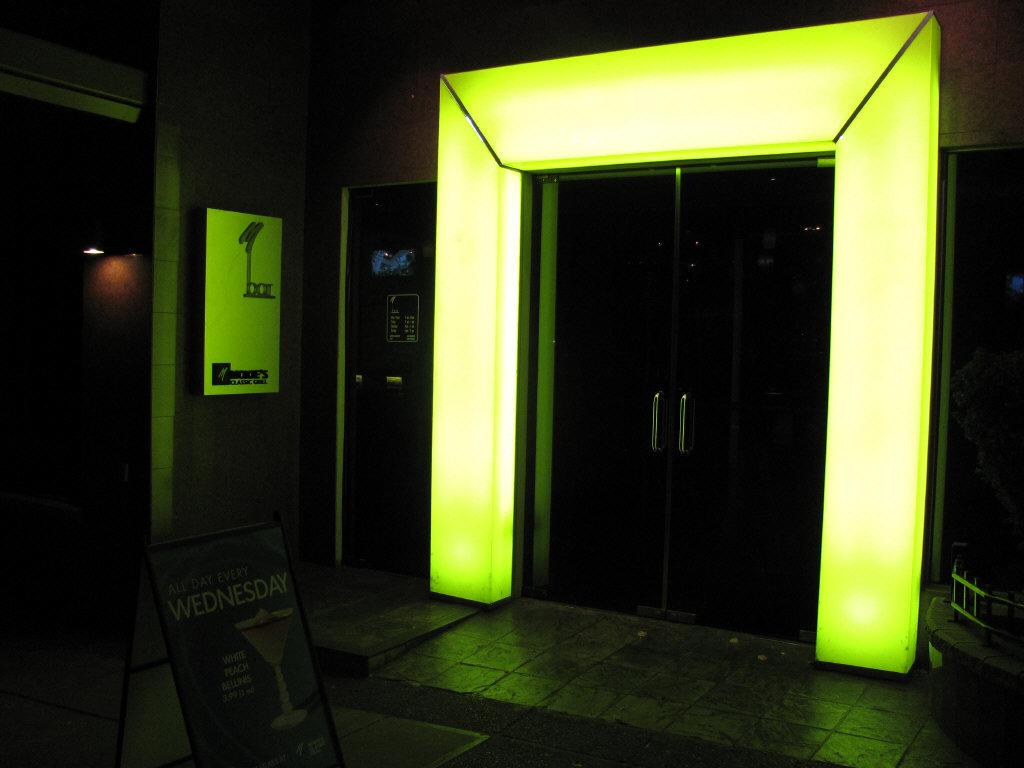What is located at the bottom of the image? There is a board at the bottom of the image. What can be seen in the middle of the image? There is a door in the middle of the image. Where is the light source located in the image? The light is on the left side of the image. Can you see a train passing by in the image? There is no train present in the image. Is your grandmother in the image holding a bowl of cherries? There is no grandmother or cherries present in the image. 